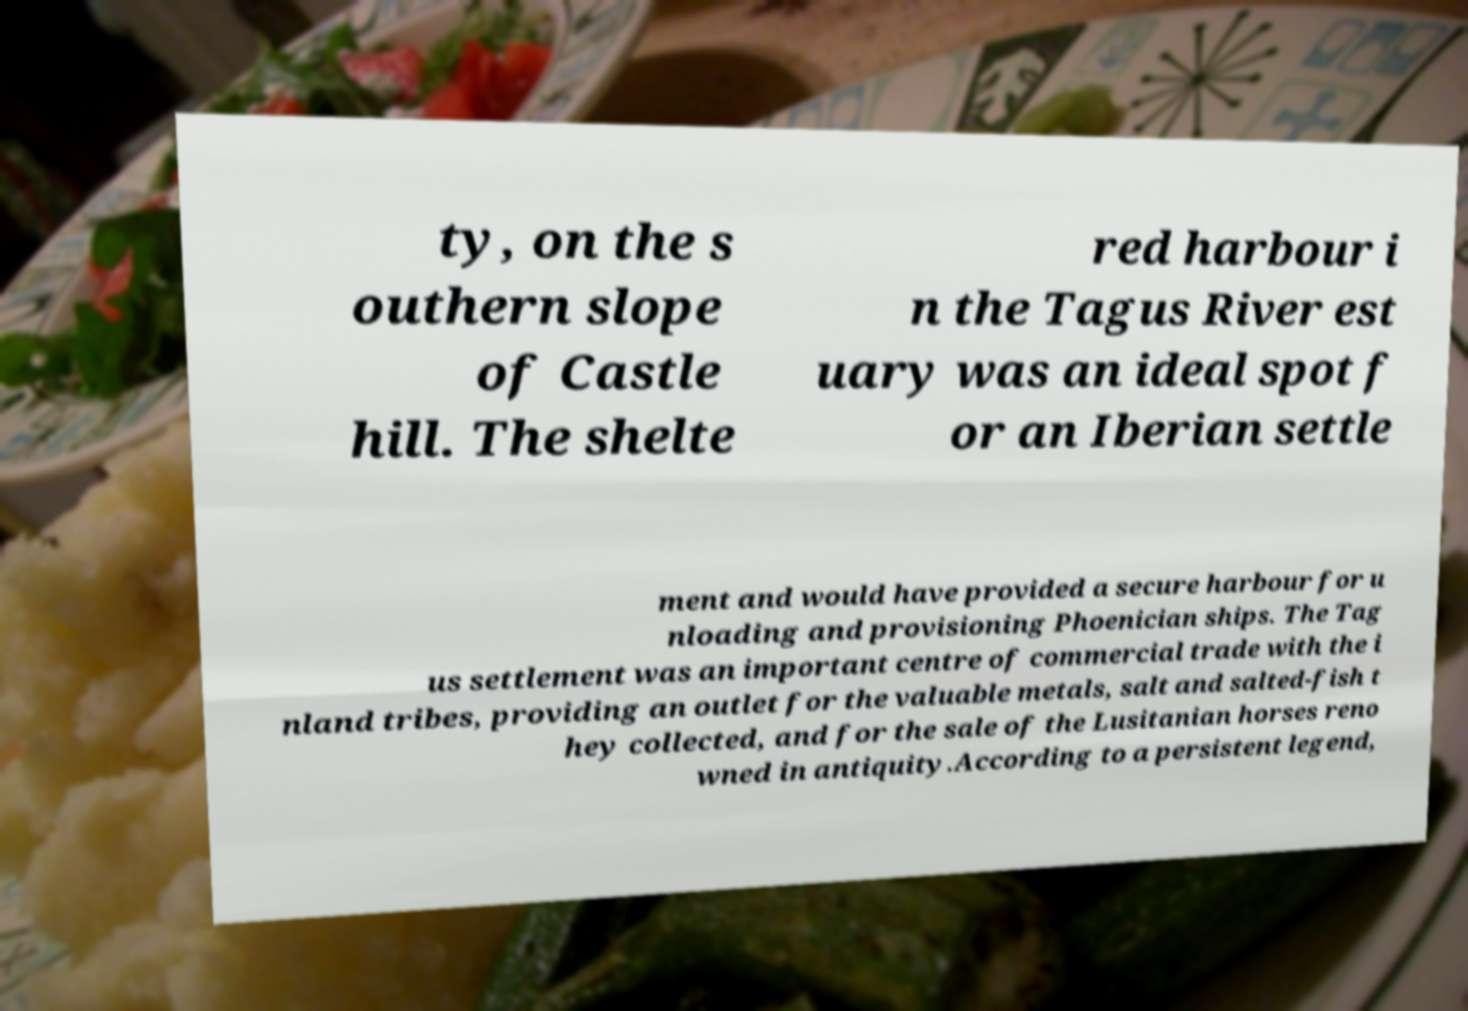What messages or text are displayed in this image? I need them in a readable, typed format. ty, on the s outhern slope of Castle hill. The shelte red harbour i n the Tagus River est uary was an ideal spot f or an Iberian settle ment and would have provided a secure harbour for u nloading and provisioning Phoenician ships. The Tag us settlement was an important centre of commercial trade with the i nland tribes, providing an outlet for the valuable metals, salt and salted-fish t hey collected, and for the sale of the Lusitanian horses reno wned in antiquity.According to a persistent legend, 